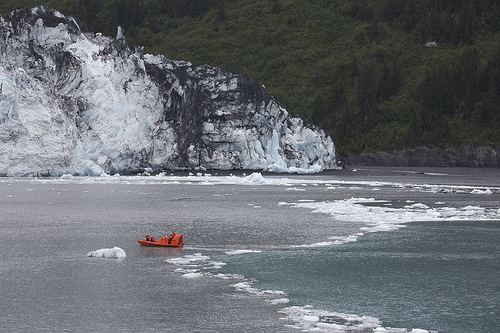<image>
Is the forest behind the mountain? Yes. From this viewpoint, the forest is positioned behind the mountain, with the mountain partially or fully occluding the forest. 